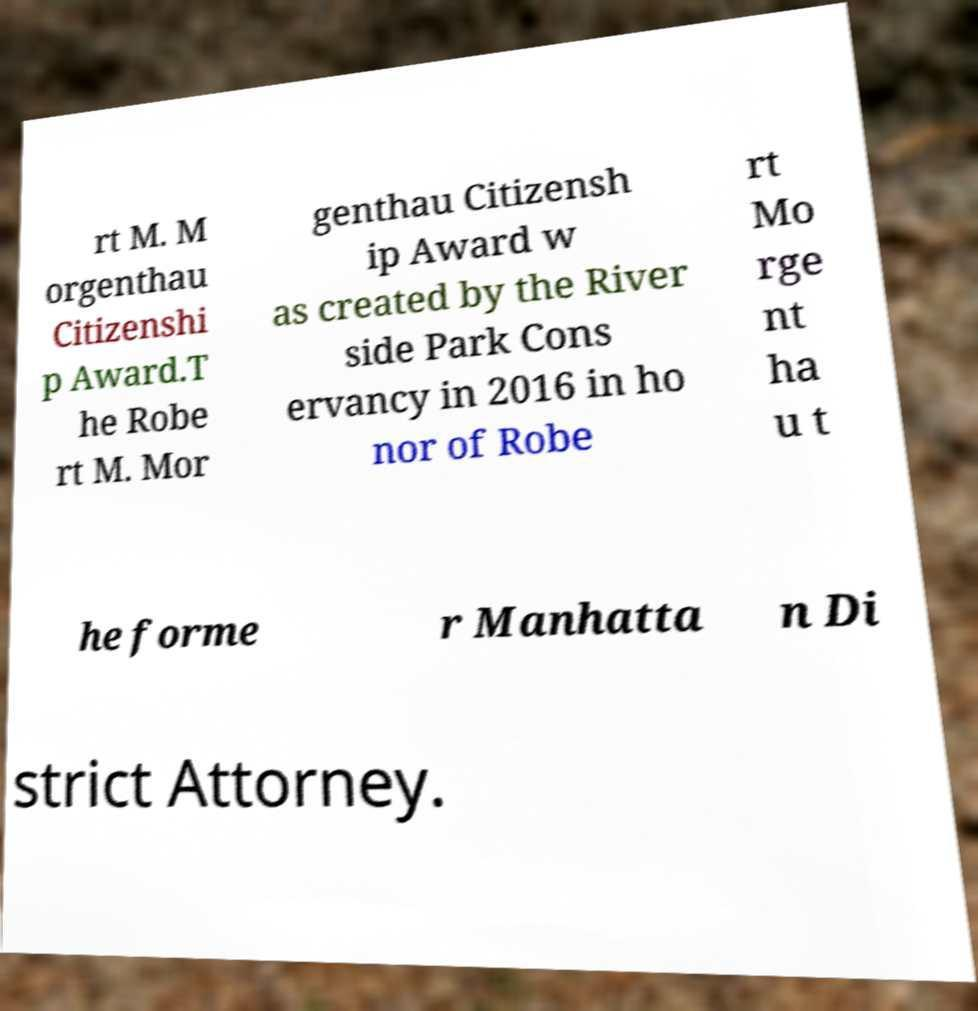There's text embedded in this image that I need extracted. Can you transcribe it verbatim? rt M. M orgenthau Citizenshi p Award.T he Robe rt M. Mor genthau Citizensh ip Award w as created by the River side Park Cons ervancy in 2016 in ho nor of Robe rt Mo rge nt ha u t he forme r Manhatta n Di strict Attorney. 